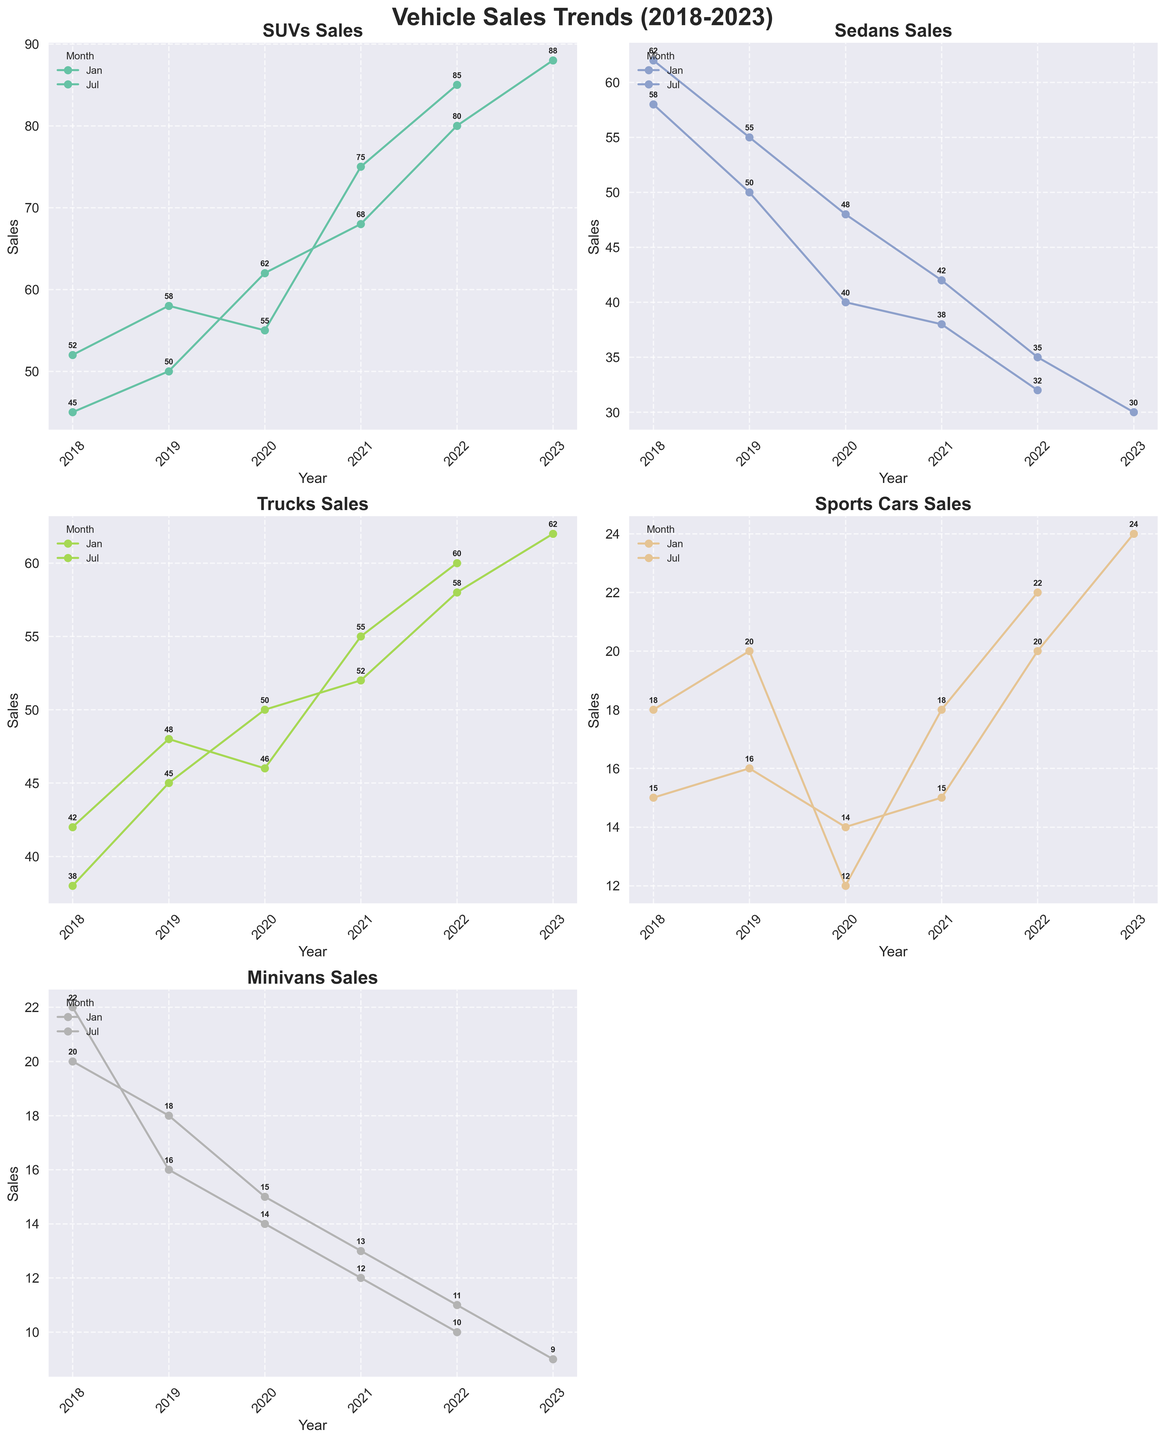What is the overall trend in SUV sales from 2018 to 2023? To see the trend in SUV sales, refer to the SUV Sales subplot. The sales start at 45 in Jan 2018 and consistently rise over the years, reaching 88 by Jan 2023. This suggests an overall upward trend.
Answer: Upward trend Which month consistently shows higher sales for Trucks, January or July? Compare the sales values for Trucks in January and July over the years in the Trucks Sales subplot. January values are consistently lower than July values. For example, in 2018, January sales are 38 whereas July sales are 42, and similarly in other years.
Answer: July In which year did Minivans have the lowest sales, and what was the value? Look at the Minivans Sales subplot to find the lowest point on the graph. The lowest sales for Minivans occur in January 2023 with a value of 9.
Answer: 2023, 9 How do the sales of Sports Cars in January compare with those in July? For each year, compare the points of Sports Cars Sales in January and July. In 2018, January is 15 and July is 18, and similarly more in other years. July consistently has higher sales compared to January.
Answer: July is consistently higher Calculate the average SUV sales in January for the years 2018 to 2023. To find the average, add the sales figures for January across specified years (45 + 50 + 62 + 68 + 80 + 88) and divide by the number of years (6). (45+50+62+68+80+88)/6 = 65.5
Answer: 65.5 Which vehicle type shows the most rapid increase in sales from 2018 to 2023? Compare the starting and ending sales points of each vehicle type. SUVs begin at 45 in Jan 2018 and end at 88 in Jan 2023, a net increase of 43, the highest among all vehicle types.
Answer: SUVs Between SUVs and Sedans, which vehicle type experienced a more stable sales trend over the years? Referencing both SUVs and Sedans Sales subplots, notice the fluctuating pattern for Sedans while SUVs show a steady rise with less fluctuation. SUVs experience a more stable upward trend.
Answer: SUVs Did any vehicle type experience a consistent decline in sales over the 5-year period? Analyze each subplot for consistent declines. Sedans show a declining trend from Jan 2018 (62) to Jan 2023 (30), consistently going down each year.
Answer: Sedans How did the sales of Trucks change from January 2020 to January 2021? Focus on the Truck Sales subplot. In January 2020, sales were 50, and in January 2021, sales were 52, indicating a slight increase.
Answer: Increase What can be inferred about the popularity of SUVs compared to Minivans over the years? Comparing the sales trends in their respective subplots, SUVs have a steady increase and higher sales numbers, while Minivans show a decline. SUVs are becoming more popular compared to Minivans.
Answer: SUVs more popular 